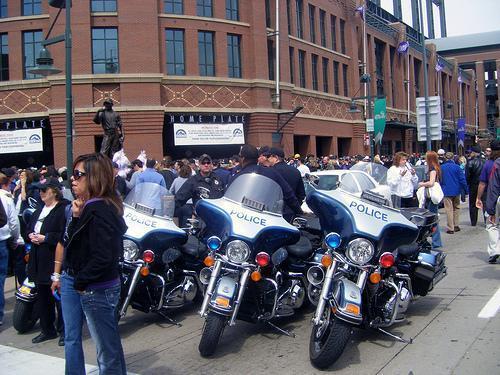How many motorcycles are there?
Give a very brief answer. 4. How many people are fighting each other?
Give a very brief answer. 0. 